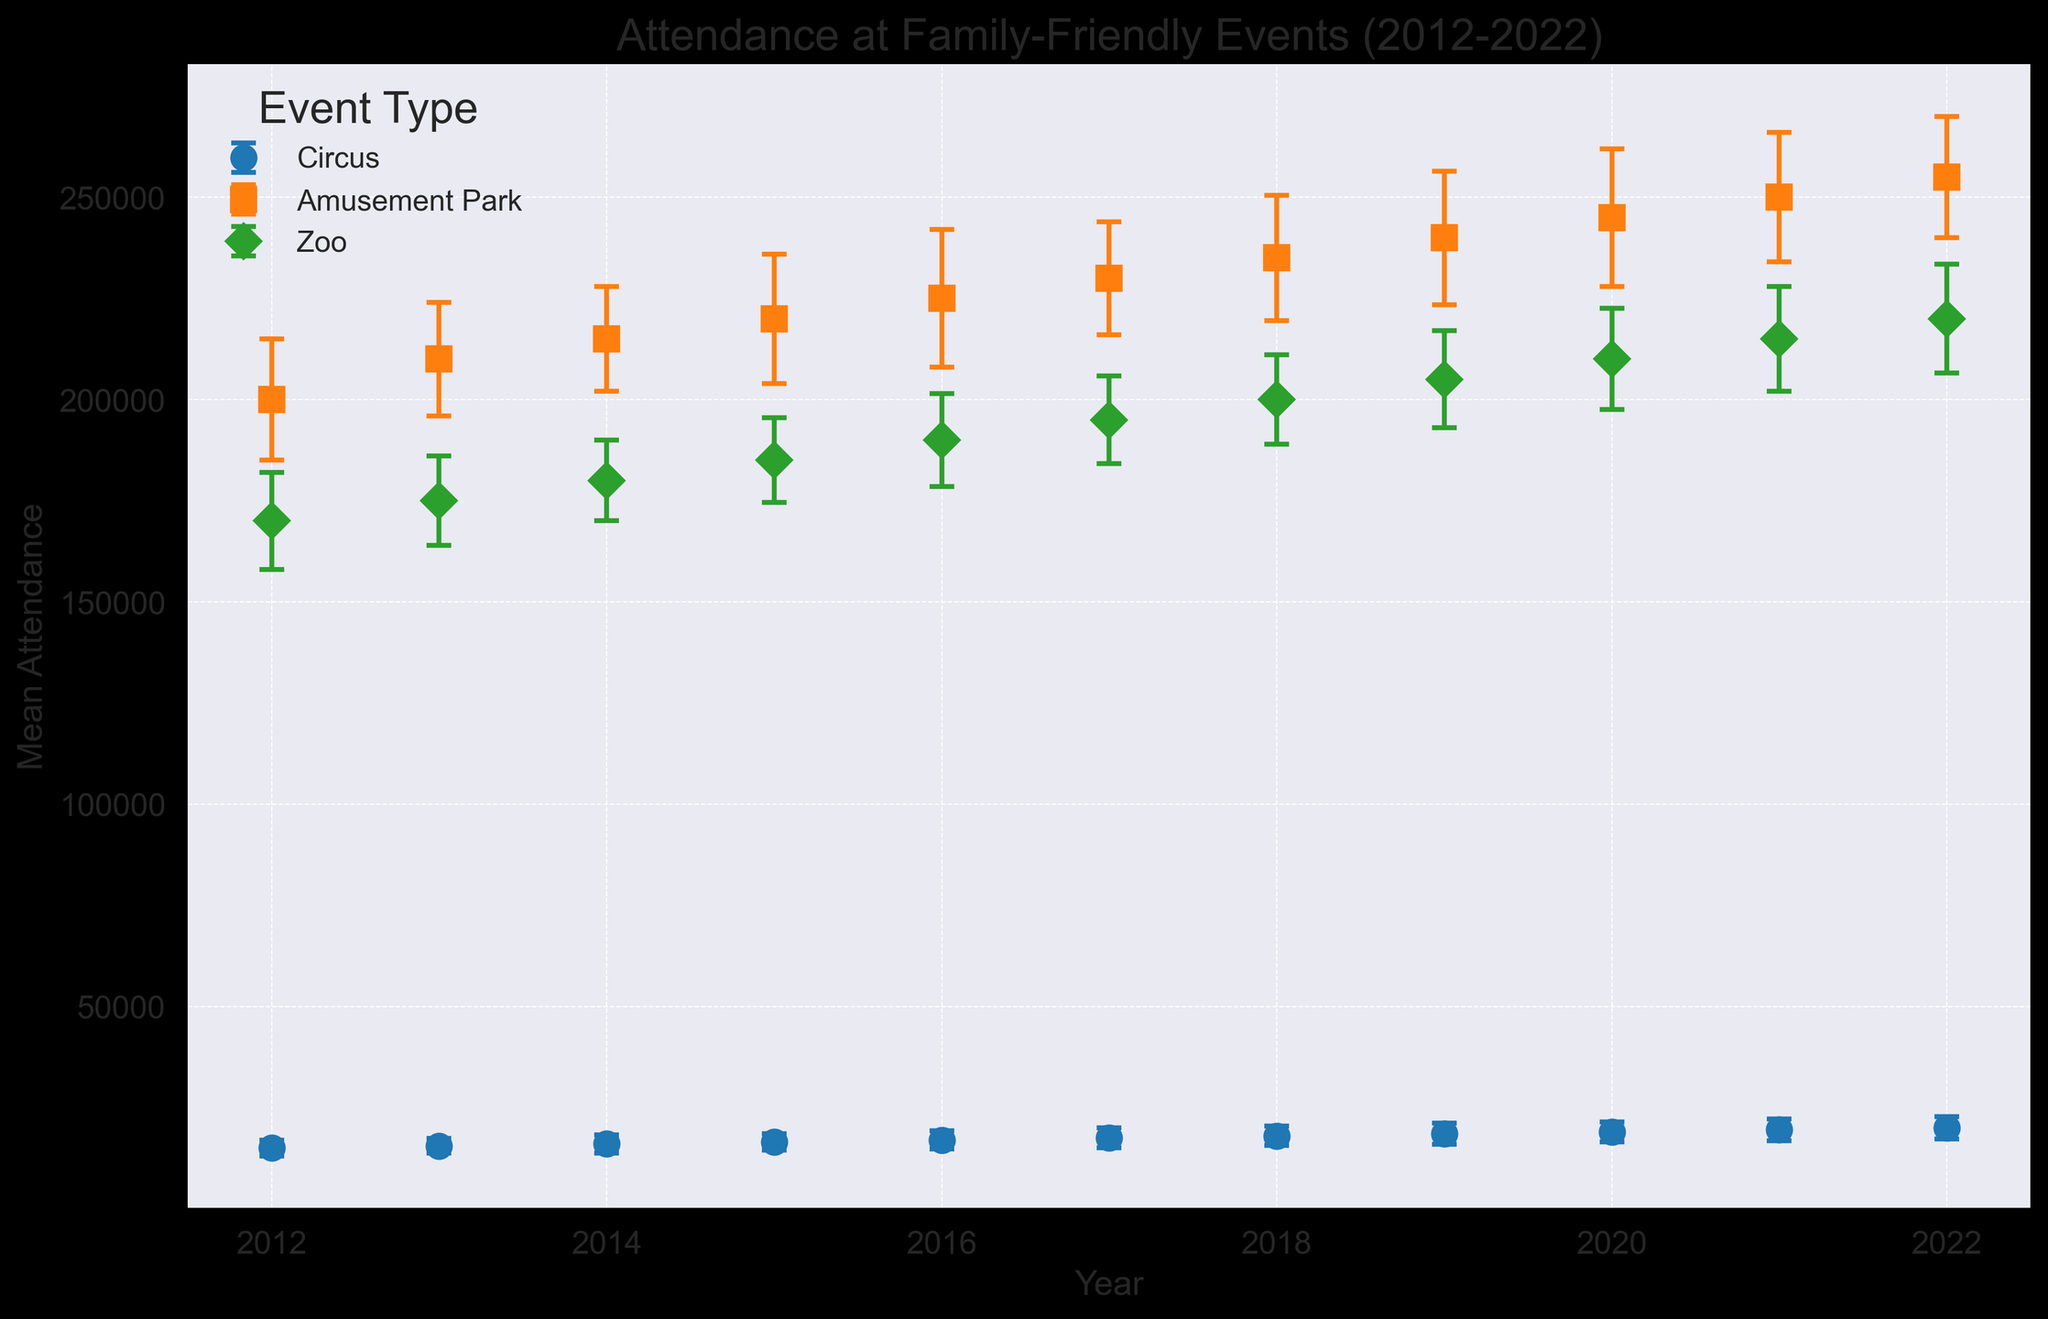Which event had the highest mean attendance in 2020? From the figure, look for the year 2020 and identify the event with the highest mean attendance bar. This event will have the tallest bar comparing others in the same year.
Answer: Amusement Park What was the mean attendance trend for the circus from 2012 to 2022? Observe the points and error bars specific to the "Circus" event from 2012 to 2022 in the figure. Note if the attendance values are increasing, decreasing, or remaining constant over time.
Answer: Increasing Between 2016 and 2021, which event's mean attendance changed the most? Look at the mean attendance values for each event between 2016 and 2021. Calculate the difference for each event type and compare these differences to find the event with the greatest change.
Answer: Amusement Park How does the mean attendance for the zoo in 2012 compare with the circus in 2022? Locate the mean attendance values for the zoo in 2012 and the circus in 2022 from the figure, then compare these two values directly.
Answer: Zoo in 2012 is higher What was the mean attendance for amusement parks in 2015? Identify the "Amusement Park" event for the year 2015 in the figure. The mean attendance is represented by a specific bar/point in that section.
Answer: 220,000 What is the average mean attendance across all events for the year 2018? Sum the mean attendance of circus, amusement park, and zoo for 2018 and divide by the number of events (3). Specifically, (18,000 + 235,000 + 200,000) / 3.
Answer: 151,000 Which year shows the largest error bar for the circus? Look at the error bars associated with the circus plots for each year and identify the longest error bar.
Answer: 2022 By how much did the mean attendance of zoos increase from 2018 to 2022? Subtract the mean attendance of zoos in 2018 from the mean attendance in 2022 (220,000 - 200,000).
Answer: 20,000 For which year is the mean attendance for all events the closest to each other? Evaluate the mean attendance for each event type across all years and identify the year where the mean attendance values are the most similar.
Answer: 2013 